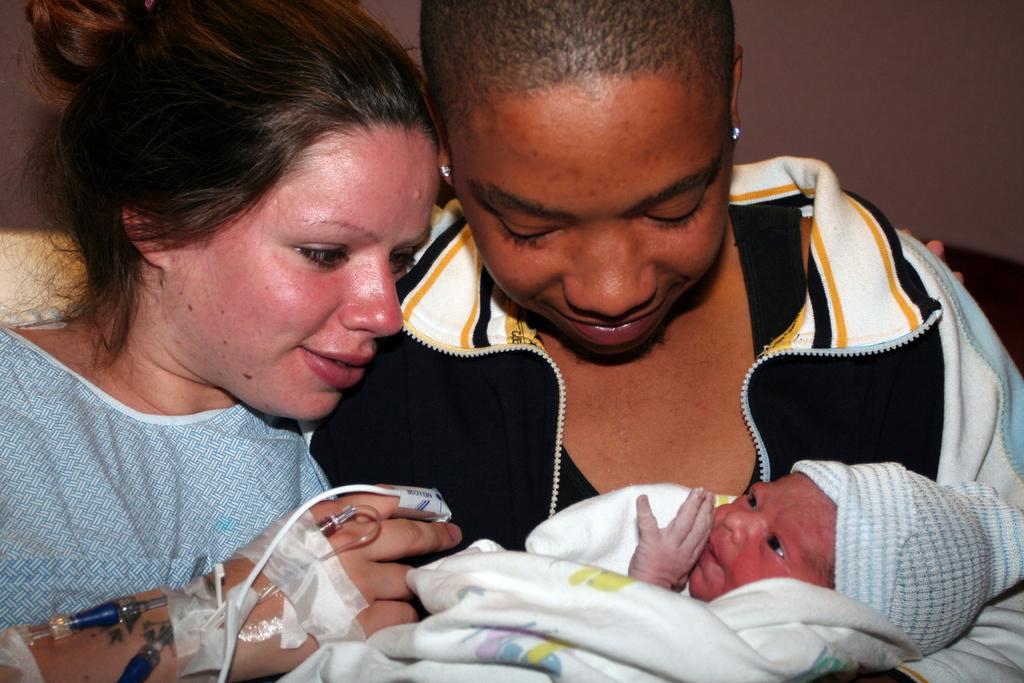Could you give a brief overview of what you see in this image? In this picture we can see there are two persons holding a baby. Behind the people, there is a wall. 